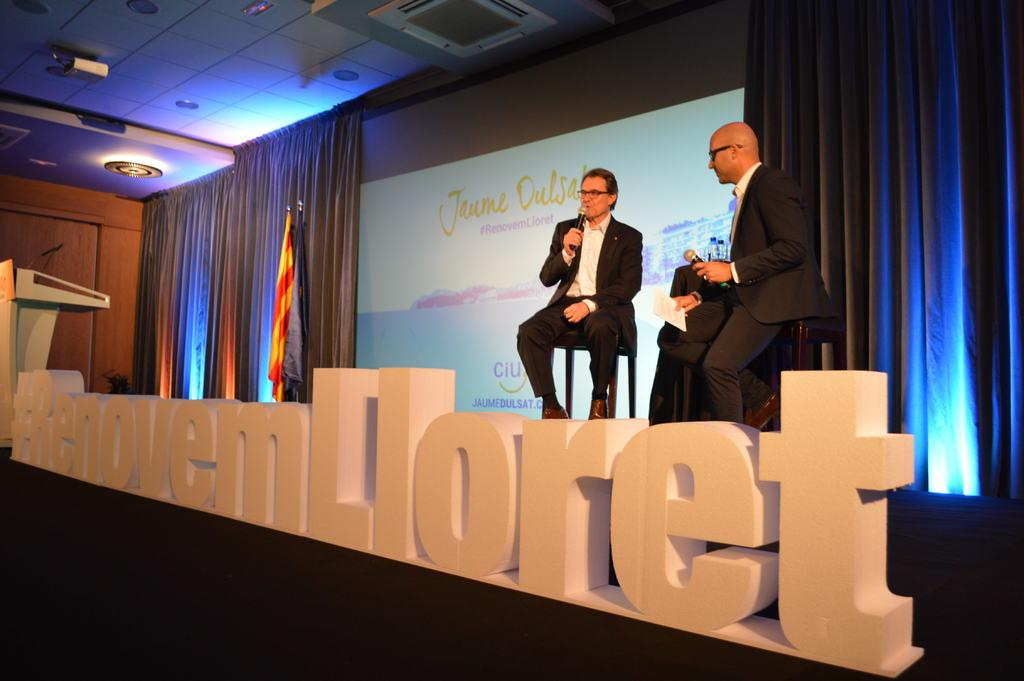<image>
Summarize the visual content of the image. Two men standing over a large hash tag sign. 